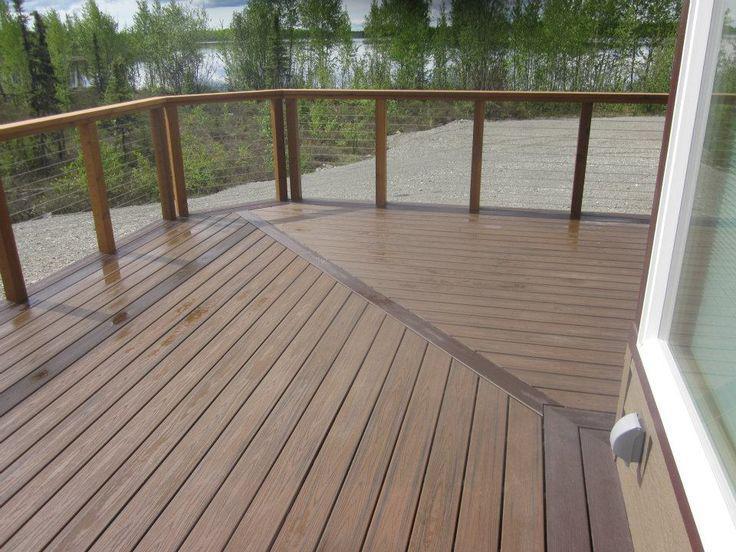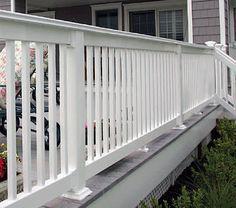The first image is the image on the left, the second image is the image on the right. Evaluate the accuracy of this statement regarding the images: "At least one railing is white.". Is it true? Answer yes or no. Yes. 